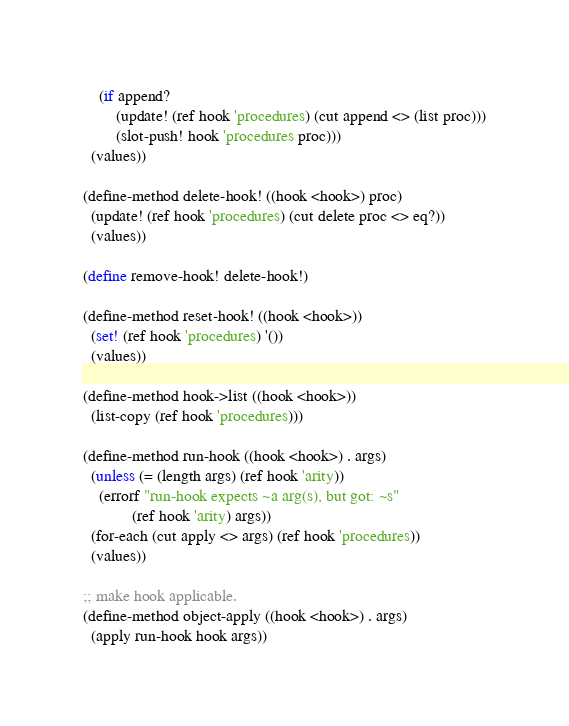<code> <loc_0><loc_0><loc_500><loc_500><_Scheme_>    (if append?
        (update! (ref hook 'procedures) (cut append <> (list proc)))
        (slot-push! hook 'procedures proc)))
  (values))

(define-method delete-hook! ((hook <hook>) proc)
  (update! (ref hook 'procedures) (cut delete proc <> eq?))
  (values))

(define remove-hook! delete-hook!)

(define-method reset-hook! ((hook <hook>))
  (set! (ref hook 'procedures) '())
  (values))

(define-method hook->list ((hook <hook>))
  (list-copy (ref hook 'procedures)))

(define-method run-hook ((hook <hook>) . args)
  (unless (= (length args) (ref hook 'arity))
    (errorf "run-hook expects ~a arg(s), but got: ~s"
            (ref hook 'arity) args))
  (for-each (cut apply <> args) (ref hook 'procedures))
  (values))

;; make hook applicable.
(define-method object-apply ((hook <hook>) . args)
  (apply run-hook hook args))

</code> 